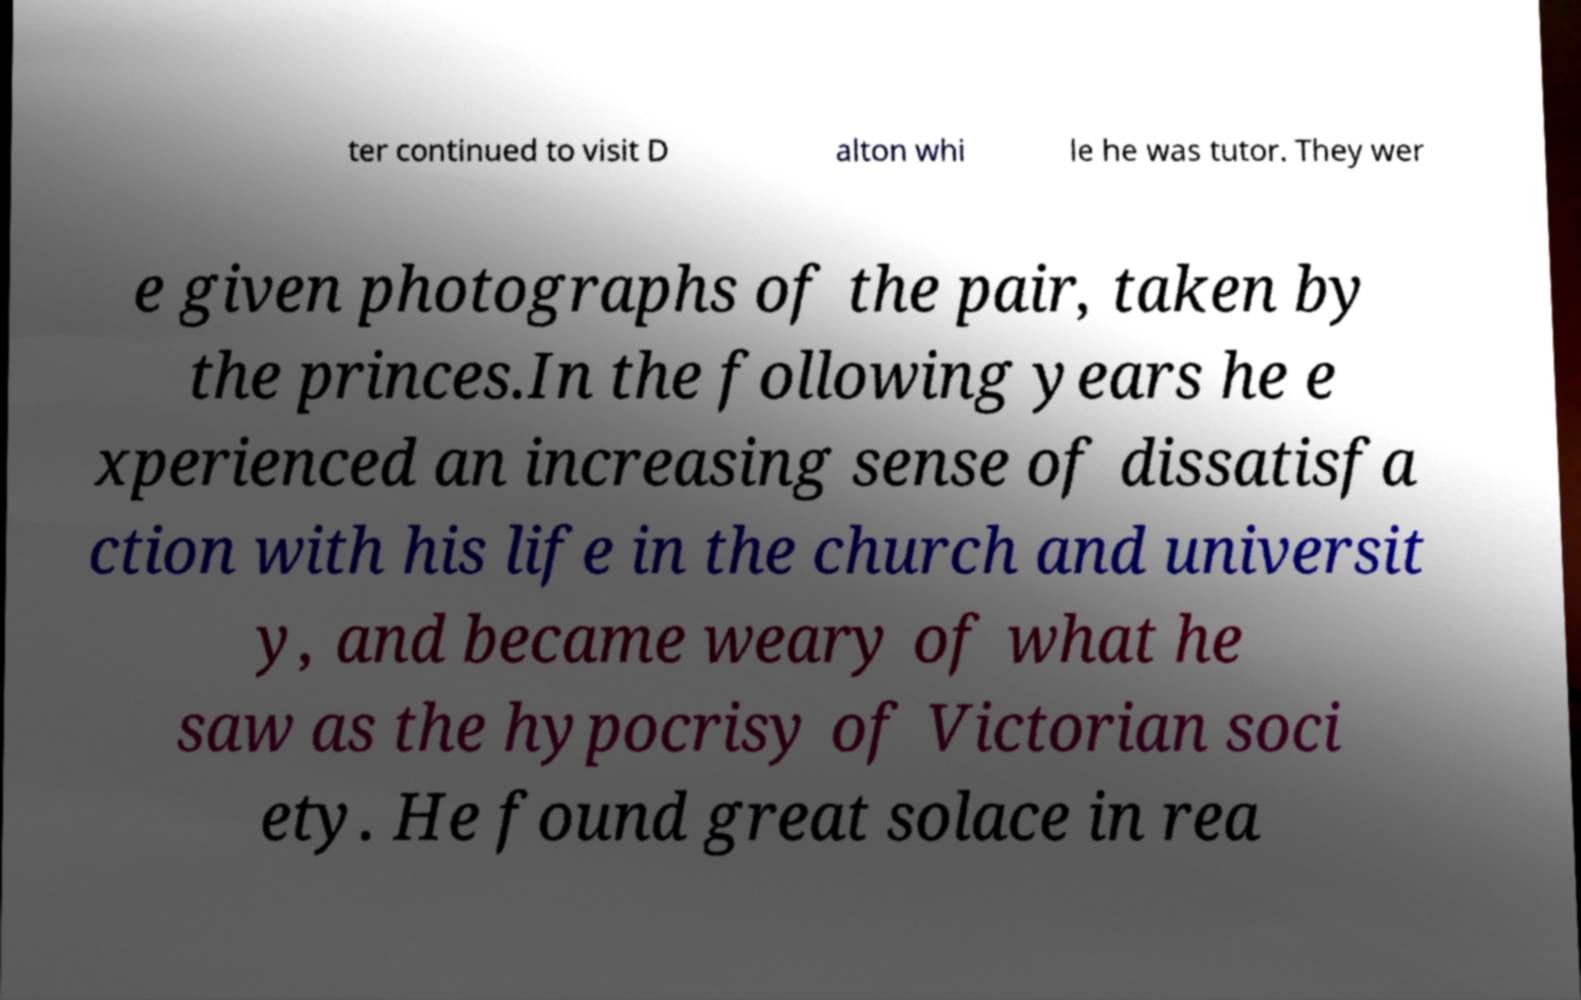There's text embedded in this image that I need extracted. Can you transcribe it verbatim? ter continued to visit D alton whi le he was tutor. They wer e given photographs of the pair, taken by the princes.In the following years he e xperienced an increasing sense of dissatisfa ction with his life in the church and universit y, and became weary of what he saw as the hypocrisy of Victorian soci ety. He found great solace in rea 